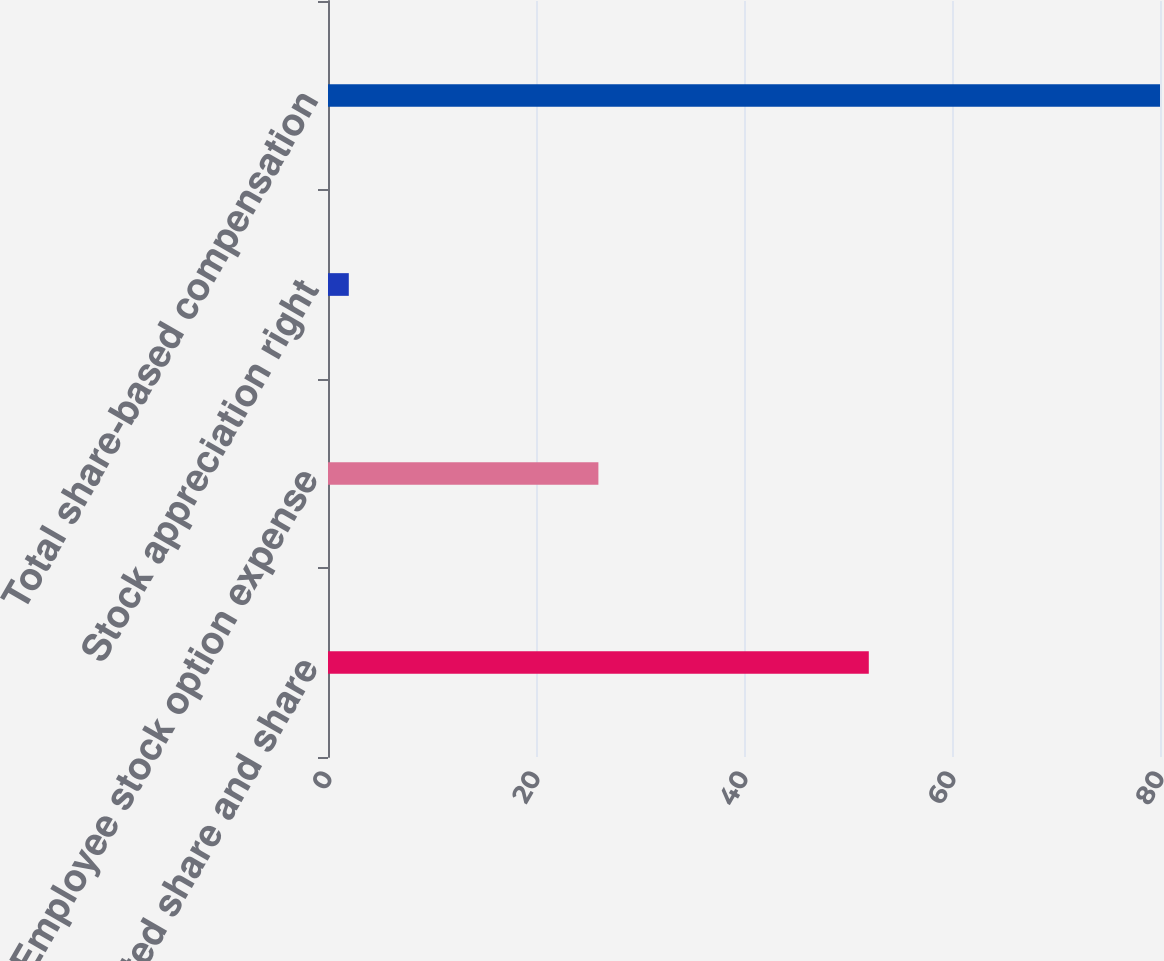Convert chart. <chart><loc_0><loc_0><loc_500><loc_500><bar_chart><fcel>Restricted share and share<fcel>Employee stock option expense<fcel>Stock appreciation right<fcel>Total share-based compensation<nl><fcel>52<fcel>26<fcel>2<fcel>80<nl></chart> 